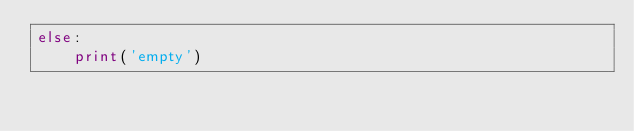<code> <loc_0><loc_0><loc_500><loc_500><_Python_>else:
    print('empty')
</code> 